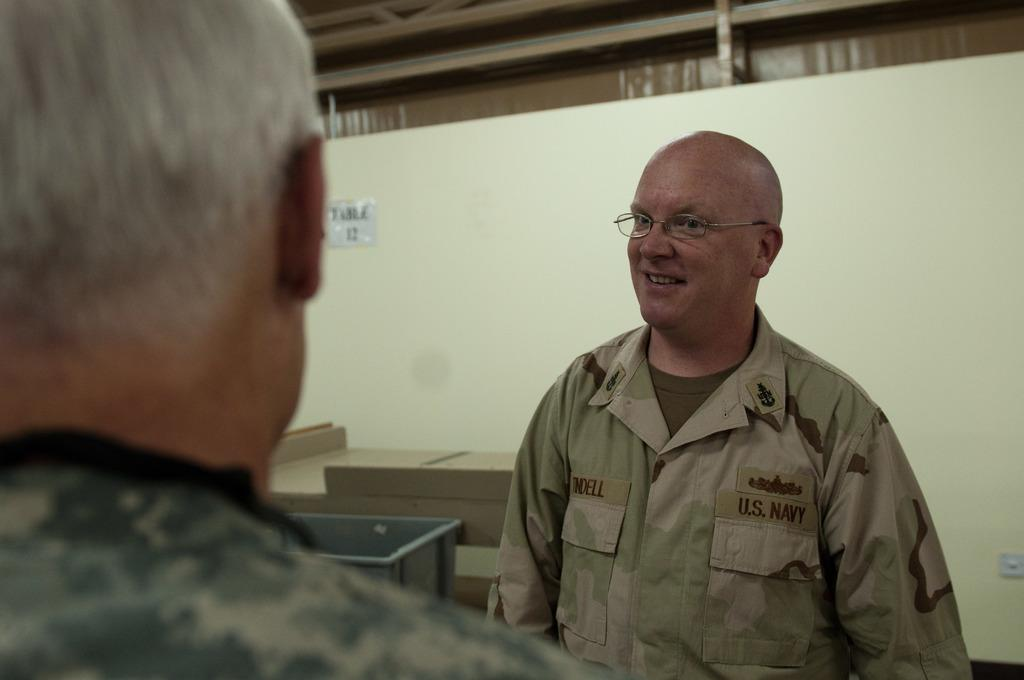How many people are in the image? There are two persons standing in the middle of the image. What is located behind the persons? There is a table behind the persons. What is on the wall behind the table? There is a poster on the wall. What type of lettuce is featured in the poster on the wall? There is no lettuce present in the image, and the poster does not feature any lettuce. 